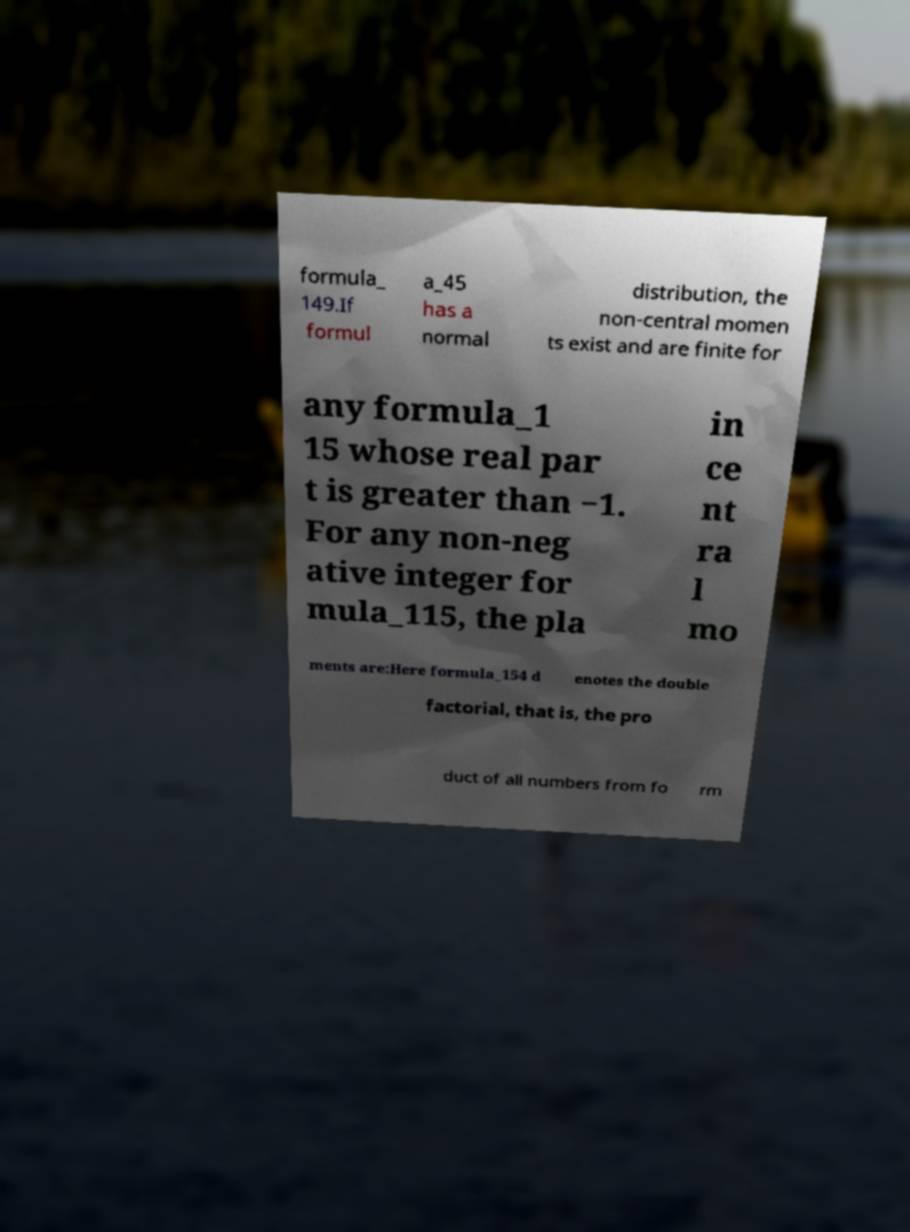For documentation purposes, I need the text within this image transcribed. Could you provide that? formula_ 149.If formul a_45 has a normal distribution, the non-central momen ts exist and are finite for any formula_1 15 whose real par t is greater than −1. For any non-neg ative integer for mula_115, the pla in ce nt ra l mo ments are:Here formula_154 d enotes the double factorial, that is, the pro duct of all numbers from fo rm 